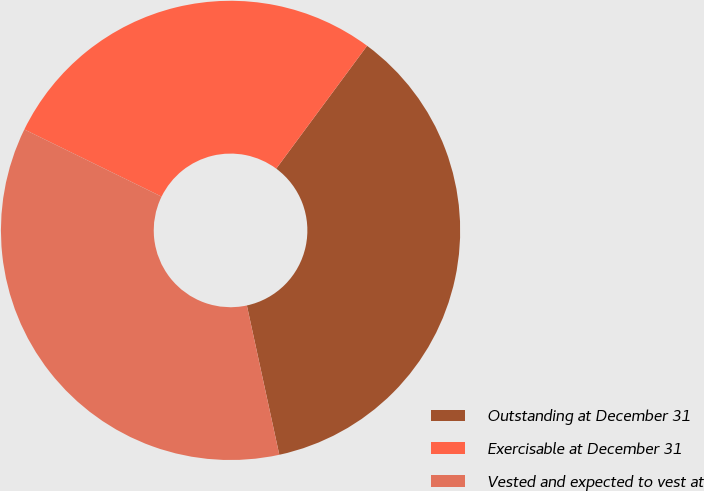Convert chart to OTSL. <chart><loc_0><loc_0><loc_500><loc_500><pie_chart><fcel>Outstanding at December 31<fcel>Exercisable at December 31<fcel>Vested and expected to vest at<nl><fcel>36.46%<fcel>27.89%<fcel>35.65%<nl></chart> 